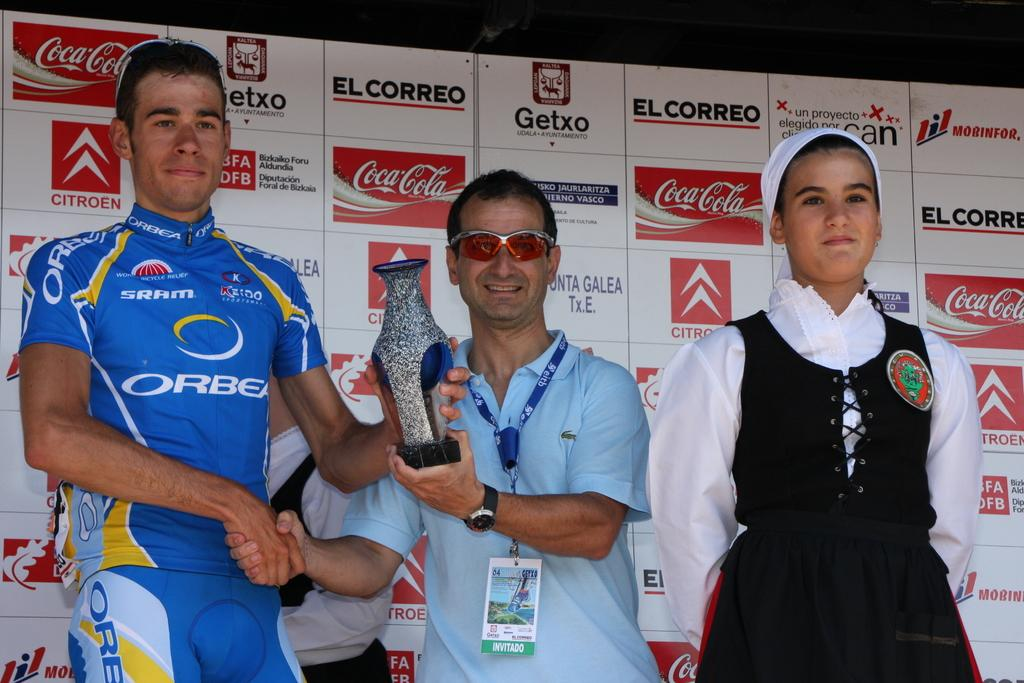Provide a one-sentence caption for the provided image. A big sponsor of the event is Coca-Cola. 